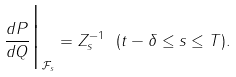Convert formula to latex. <formula><loc_0><loc_0><loc_500><loc_500>\frac { d P } { d Q } \Big | _ { \mathcal { F } _ { s } } = Z _ { s } ^ { - 1 } \ ( t - \delta \leq s \leq T ) .</formula> 